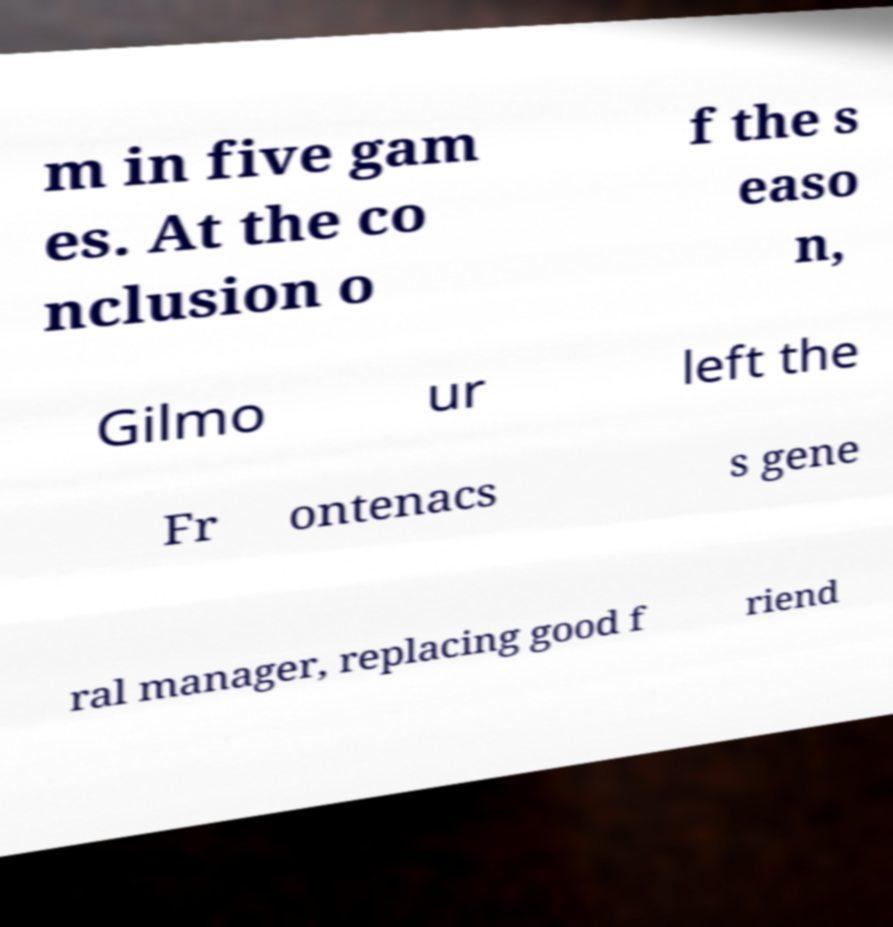There's text embedded in this image that I need extracted. Can you transcribe it verbatim? m in five gam es. At the co nclusion o f the s easo n, Gilmo ur left the Fr ontenacs s gene ral manager, replacing good f riend 